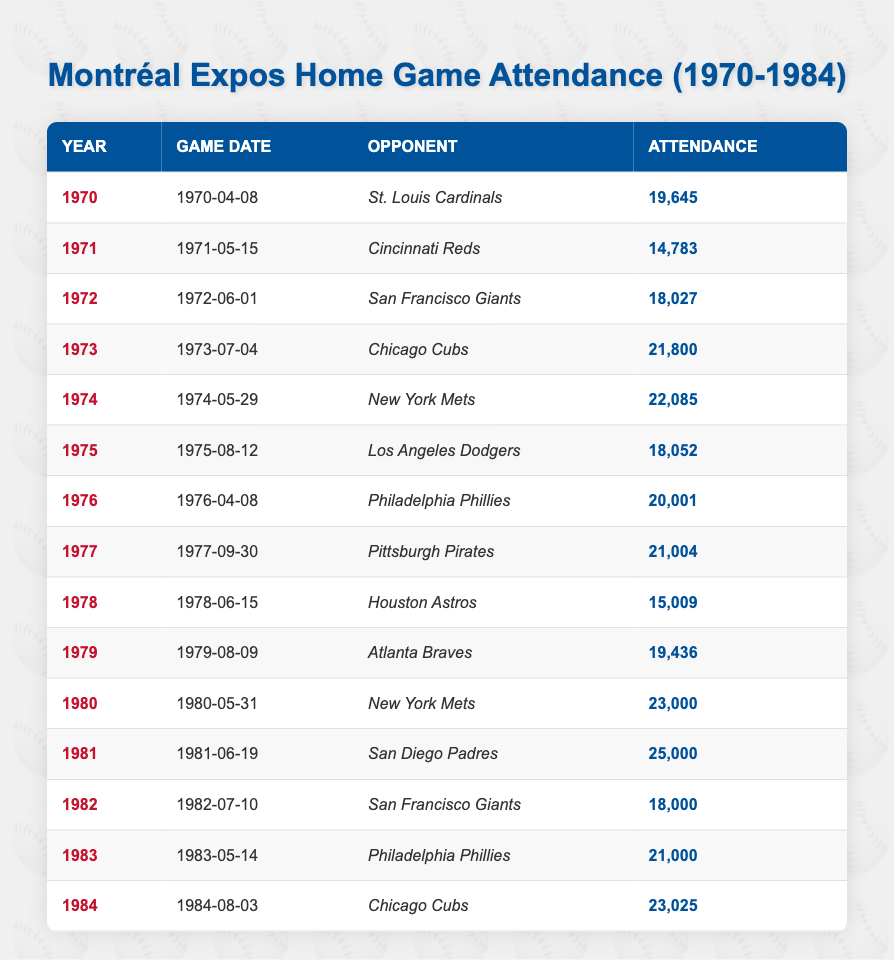What was the attendance on June 1, 1972? The table shows a game against the San Francisco Giants on that date with an attendance of 18,027.
Answer: 18,027 In which year did the Montréal Expos have the highest attendance for a single game? The highest attendance in the table is 25,000 on June 19, 1981, against the San Diego Padres.
Answer: 1981 What is the total attendance for the year 1980? The attendance for the game in 1980 (23,000) is the only entry for that year, so the total is the same as the game attendance, which is 23,000.
Answer: 23,000 Did the attendance ever fall below 15,000 in any of the games? Yes, the attendance fell to 15,009 on June 15, 1978, against the Houston Astros.
Answer: Yes What is the average attendance from 1970 to 1984? First, sum the attendance values: 19,645 + 14,783 + 18,027 + 21,800 + 22,085 + 18,052 + 20,001 + 21,004 + 15,009 + 19,436 + 23,000 + 25,000 + 18,000 + 21,000 + 23,025 =  392,812. There are 15 entries, so the average is 392,812 / 15 = 26,187.47, rounded down to 26,187.
Answer: 26,187 How many games had an attendance of over 20,000? There are six instances in the table where attendance exceeded 20,000: 21,800 (1973), 22,085 (1974), 23,000 (1980), 25,000 (1981), 21,004 (1983), and 23,025 (1984).
Answer: 6 